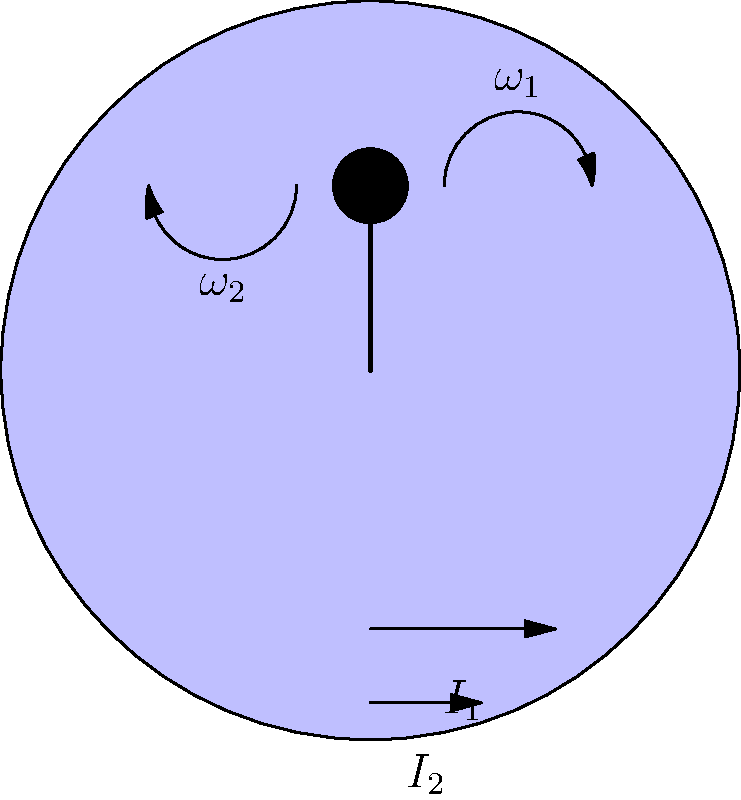In figure skating, a skater starts spinning with their arms extended and then pulls them in close to their body. If the initial angular velocity is $\omega_1$ and the initial moment of inertia is $I_1$, what is the final angular velocity $\omega_2$ when the moment of inertia decreases to $I_2$? Express your answer in terms of $\omega_1$, $I_1$, and $I_2$. Let's approach this step-by-step, keeping in mind the conservation of angular momentum:

1) The principle of conservation of angular momentum states that in the absence of external torques, the total angular momentum of a system remains constant.

2) Angular momentum is defined as the product of moment of inertia and angular velocity:
   $L = I\omega$

3) Since angular momentum is conserved, we can equate the initial and final angular momenta:
   $L_1 = L_2$
   $I_1\omega_1 = I_2\omega_2$

4) We want to solve for $\omega_2$, so let's rearrange the equation:
   $\omega_2 = \frac{I_1\omega_1}{I_2}$

5) This equation shows that as the moment of inertia decreases (when the skater pulls their arms in), the angular velocity must increase to maintain constant angular momentum.

6) It's worth noting that this is why figure skaters spin faster when they pull their arms in close to their body - they're decreasing their moment of inertia, which results in an increase in angular velocity.
Answer: $\omega_2 = \frac{I_1\omega_1}{I_2}$ 